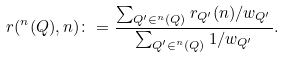Convert formula to latex. <formula><loc_0><loc_0><loc_500><loc_500>r ( ^ { n } ( Q ) , n ) \colon = \frac { \sum _ { Q ^ { \prime } \in ^ { n } ( Q ) } r _ { Q ^ { \prime } } ( n ) / w _ { Q ^ { \prime } } } { \sum _ { Q ^ { \prime } \in ^ { n } ( Q ) } 1 / w _ { Q ^ { \prime } } } .</formula> 